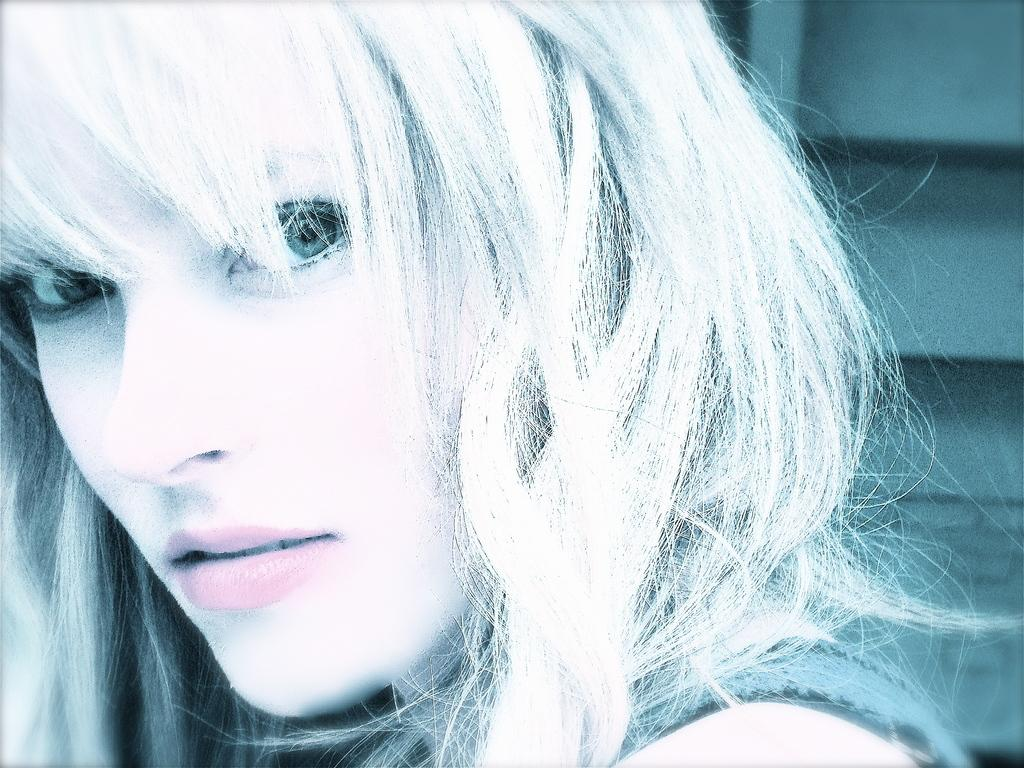Who is the main subject in the image? There is a girl in the image. What is the girl wearing? The girl is wearing a grey T-shirt. What is the girl doing in the image? The girl is looking at the camera and posing for the photo. What can be seen in the background of the image? There is a cupboard in the background of the image. Has the image been altered in any way? Yes, the image has been edited. What news headline is visible on the girl's T-shirt in the image? There is no news headline visible on the girl's T-shirt in the image. Can you see any veins on the girl's arms in the image? There is no indication of visible veins on the girl's arms in the image. 